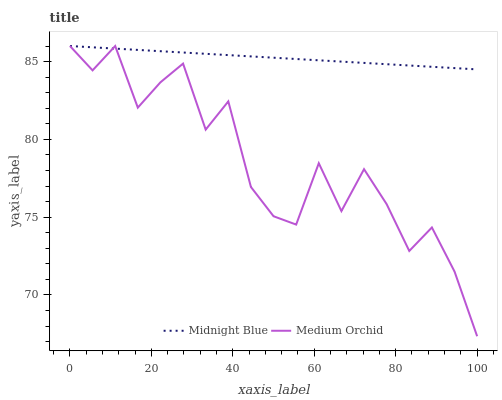Does Medium Orchid have the minimum area under the curve?
Answer yes or no. Yes. Does Midnight Blue have the maximum area under the curve?
Answer yes or no. Yes. Does Midnight Blue have the minimum area under the curve?
Answer yes or no. No. Is Midnight Blue the smoothest?
Answer yes or no. Yes. Is Medium Orchid the roughest?
Answer yes or no. Yes. Is Midnight Blue the roughest?
Answer yes or no. No. Does Medium Orchid have the lowest value?
Answer yes or no. Yes. Does Midnight Blue have the lowest value?
Answer yes or no. No. Does Midnight Blue have the highest value?
Answer yes or no. Yes. Does Medium Orchid intersect Midnight Blue?
Answer yes or no. Yes. Is Medium Orchid less than Midnight Blue?
Answer yes or no. No. Is Medium Orchid greater than Midnight Blue?
Answer yes or no. No. 